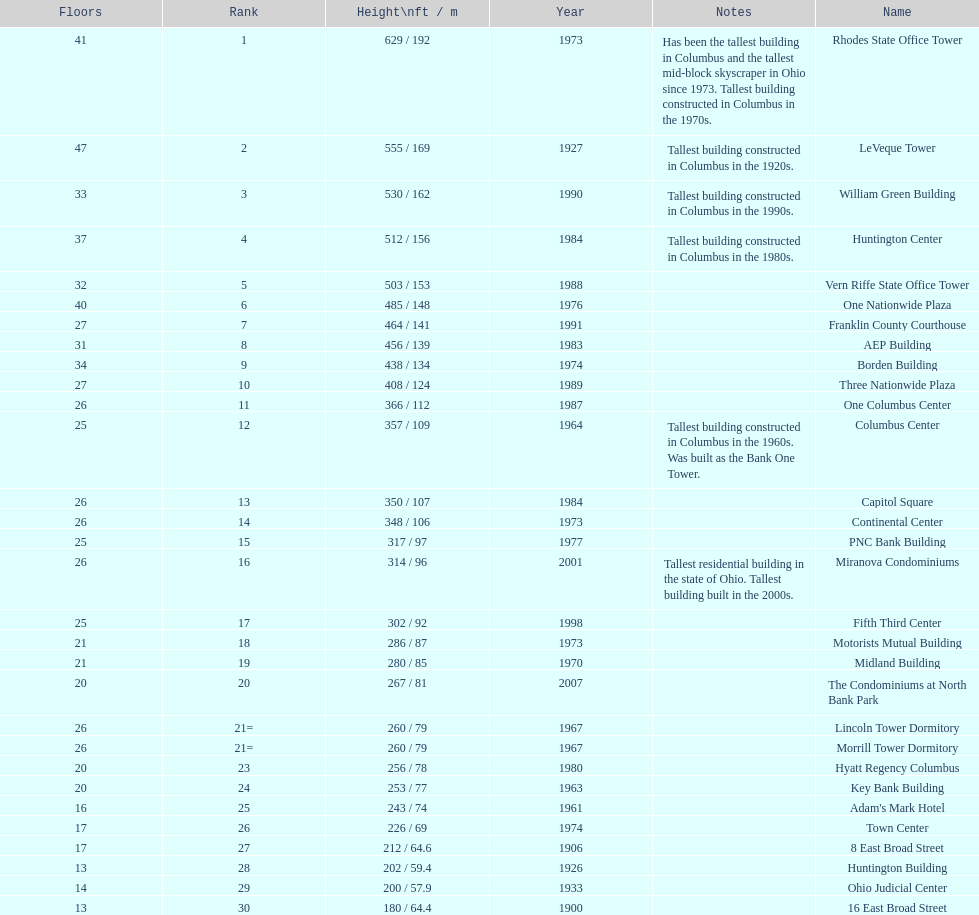What number of floors does the leveque tower have? 47. 